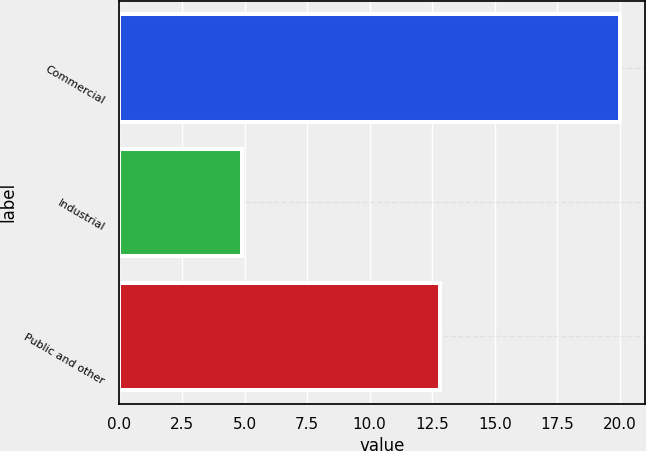Convert chart. <chart><loc_0><loc_0><loc_500><loc_500><bar_chart><fcel>Commercial<fcel>Industrial<fcel>Public and other<nl><fcel>20<fcel>4.9<fcel>12.8<nl></chart> 